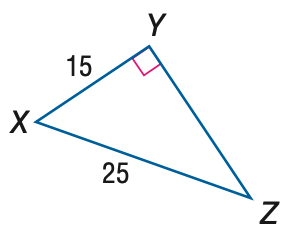Answer the mathemtical geometry problem and directly provide the correct option letter.
Question: Find the measure of \angle Z to the nearest tenth.
Choices: A: 31.0 B: 36.9 C: 53.1 D: 59.0 B 